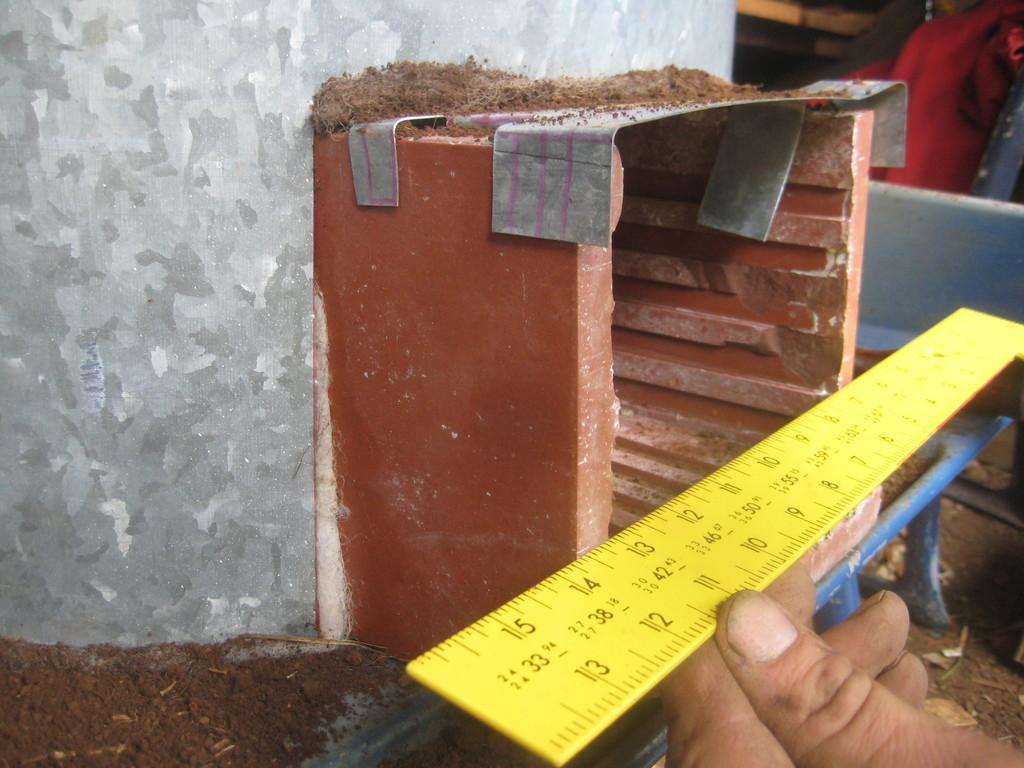<image>
Write a terse but informative summary of the picture. A 14 inch ruler is showing both inches and centimeters. 